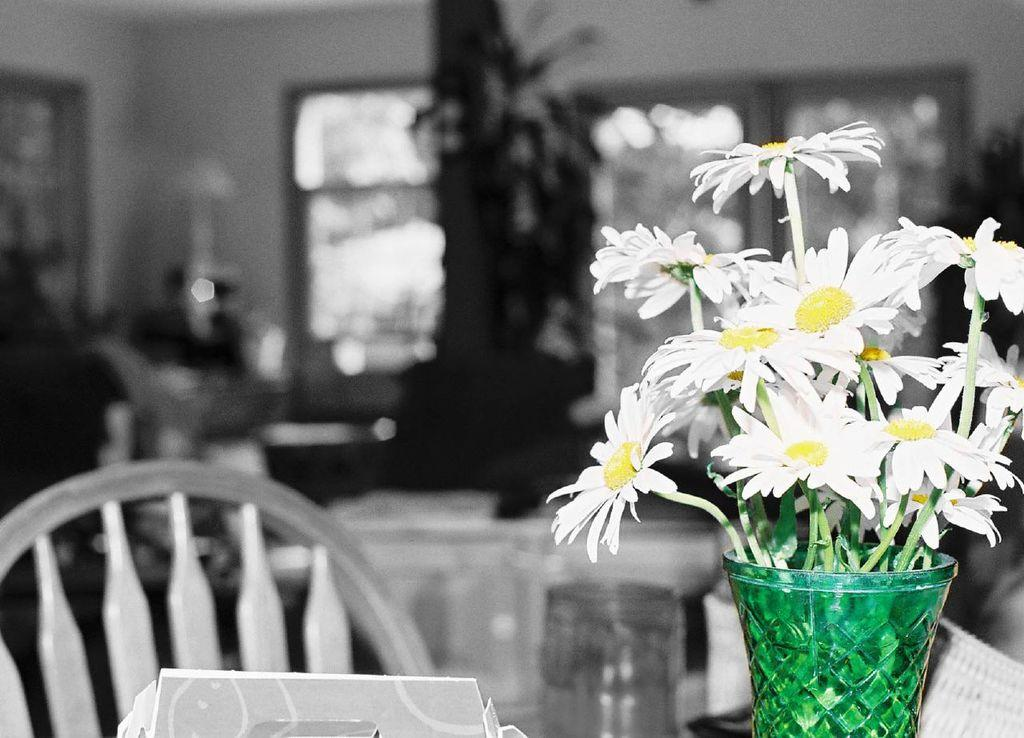What can be found in the flower vase in the image? There are flowers in a flower vase in the image. What type of furniture is present in the image? There is a chair in the image. What object in the image might be used for storage? There is a box in the image that could be used for storage. How would you describe the background of the image? The background of the image is blurry. How many cherries are on the chair in the image? There are no cherries present in the image; it features flowers in a vase, a chair, and a box. What type of letter is being delivered by the toad in the image? There is no toad or letter present in the image. 